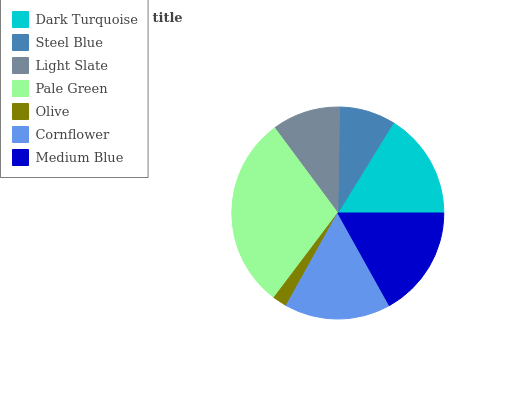Is Olive the minimum?
Answer yes or no. Yes. Is Pale Green the maximum?
Answer yes or no. Yes. Is Steel Blue the minimum?
Answer yes or no. No. Is Steel Blue the maximum?
Answer yes or no. No. Is Dark Turquoise greater than Steel Blue?
Answer yes or no. Yes. Is Steel Blue less than Dark Turquoise?
Answer yes or no. Yes. Is Steel Blue greater than Dark Turquoise?
Answer yes or no. No. Is Dark Turquoise less than Steel Blue?
Answer yes or no. No. Is Cornflower the high median?
Answer yes or no. Yes. Is Cornflower the low median?
Answer yes or no. Yes. Is Pale Green the high median?
Answer yes or no. No. Is Steel Blue the low median?
Answer yes or no. No. 